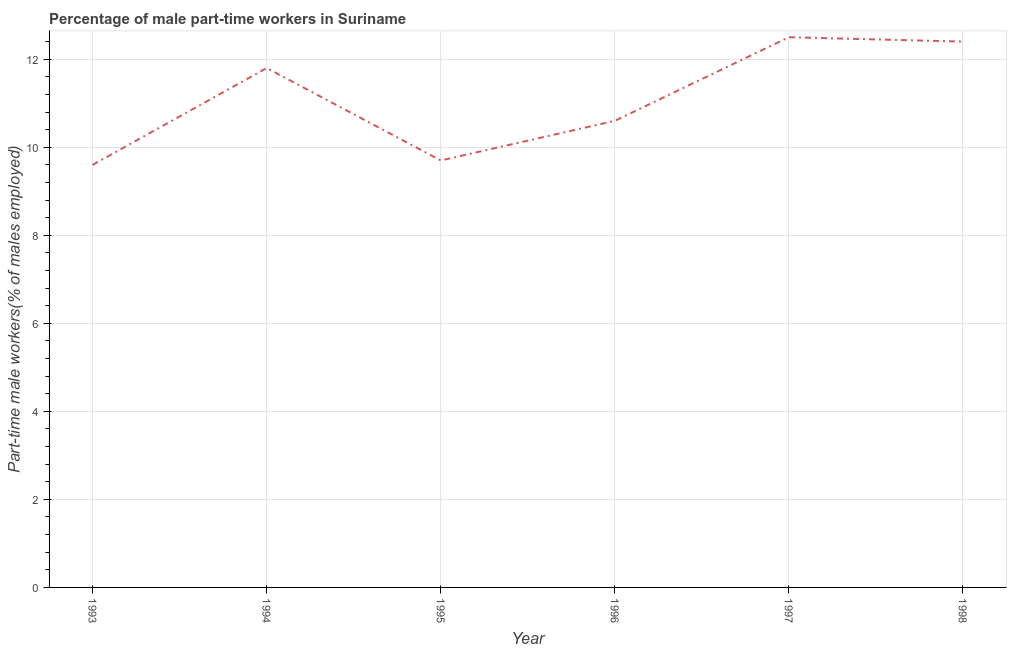What is the percentage of part-time male workers in 1993?
Ensure brevity in your answer.  9.6. Across all years, what is the minimum percentage of part-time male workers?
Offer a very short reply. 9.6. In which year was the percentage of part-time male workers maximum?
Offer a terse response. 1997. What is the sum of the percentage of part-time male workers?
Your answer should be very brief. 66.6. What is the difference between the percentage of part-time male workers in 1995 and 1997?
Offer a terse response. -2.8. What is the average percentage of part-time male workers per year?
Make the answer very short. 11.1. What is the median percentage of part-time male workers?
Offer a terse response. 11.2. What is the ratio of the percentage of part-time male workers in 1994 to that in 1995?
Ensure brevity in your answer.  1.22. Is the difference between the percentage of part-time male workers in 1993 and 1994 greater than the difference between any two years?
Ensure brevity in your answer.  No. What is the difference between the highest and the second highest percentage of part-time male workers?
Offer a terse response. 0.1. Is the sum of the percentage of part-time male workers in 1996 and 1998 greater than the maximum percentage of part-time male workers across all years?
Offer a terse response. Yes. What is the difference between the highest and the lowest percentage of part-time male workers?
Provide a short and direct response. 2.9. Does the percentage of part-time male workers monotonically increase over the years?
Your response must be concise. No. What is the title of the graph?
Provide a succinct answer. Percentage of male part-time workers in Suriname. What is the label or title of the X-axis?
Provide a succinct answer. Year. What is the label or title of the Y-axis?
Give a very brief answer. Part-time male workers(% of males employed). What is the Part-time male workers(% of males employed) of 1993?
Offer a terse response. 9.6. What is the Part-time male workers(% of males employed) in 1994?
Give a very brief answer. 11.8. What is the Part-time male workers(% of males employed) of 1995?
Ensure brevity in your answer.  9.7. What is the Part-time male workers(% of males employed) in 1996?
Your response must be concise. 10.6. What is the Part-time male workers(% of males employed) of 1998?
Offer a very short reply. 12.4. What is the difference between the Part-time male workers(% of males employed) in 1993 and 1995?
Your answer should be very brief. -0.1. What is the difference between the Part-time male workers(% of males employed) in 1993 and 1997?
Your answer should be compact. -2.9. What is the difference between the Part-time male workers(% of males employed) in 1993 and 1998?
Provide a short and direct response. -2.8. What is the difference between the Part-time male workers(% of males employed) in 1994 and 1995?
Your answer should be very brief. 2.1. What is the difference between the Part-time male workers(% of males employed) in 1994 and 1996?
Your answer should be compact. 1.2. What is the difference between the Part-time male workers(% of males employed) in 1994 and 1997?
Give a very brief answer. -0.7. What is the difference between the Part-time male workers(% of males employed) in 1995 and 1996?
Give a very brief answer. -0.9. What is the difference between the Part-time male workers(% of males employed) in 1995 and 1997?
Provide a succinct answer. -2.8. What is the difference between the Part-time male workers(% of males employed) in 1996 and 1998?
Offer a terse response. -1.8. What is the difference between the Part-time male workers(% of males employed) in 1997 and 1998?
Ensure brevity in your answer.  0.1. What is the ratio of the Part-time male workers(% of males employed) in 1993 to that in 1994?
Your answer should be compact. 0.81. What is the ratio of the Part-time male workers(% of males employed) in 1993 to that in 1995?
Your answer should be compact. 0.99. What is the ratio of the Part-time male workers(% of males employed) in 1993 to that in 1996?
Offer a terse response. 0.91. What is the ratio of the Part-time male workers(% of males employed) in 1993 to that in 1997?
Offer a very short reply. 0.77. What is the ratio of the Part-time male workers(% of males employed) in 1993 to that in 1998?
Ensure brevity in your answer.  0.77. What is the ratio of the Part-time male workers(% of males employed) in 1994 to that in 1995?
Your answer should be very brief. 1.22. What is the ratio of the Part-time male workers(% of males employed) in 1994 to that in 1996?
Offer a very short reply. 1.11. What is the ratio of the Part-time male workers(% of males employed) in 1994 to that in 1997?
Provide a short and direct response. 0.94. What is the ratio of the Part-time male workers(% of males employed) in 1994 to that in 1998?
Ensure brevity in your answer.  0.95. What is the ratio of the Part-time male workers(% of males employed) in 1995 to that in 1996?
Your answer should be compact. 0.92. What is the ratio of the Part-time male workers(% of males employed) in 1995 to that in 1997?
Offer a very short reply. 0.78. What is the ratio of the Part-time male workers(% of males employed) in 1995 to that in 1998?
Provide a succinct answer. 0.78. What is the ratio of the Part-time male workers(% of males employed) in 1996 to that in 1997?
Your answer should be very brief. 0.85. What is the ratio of the Part-time male workers(% of males employed) in 1996 to that in 1998?
Offer a very short reply. 0.85. 